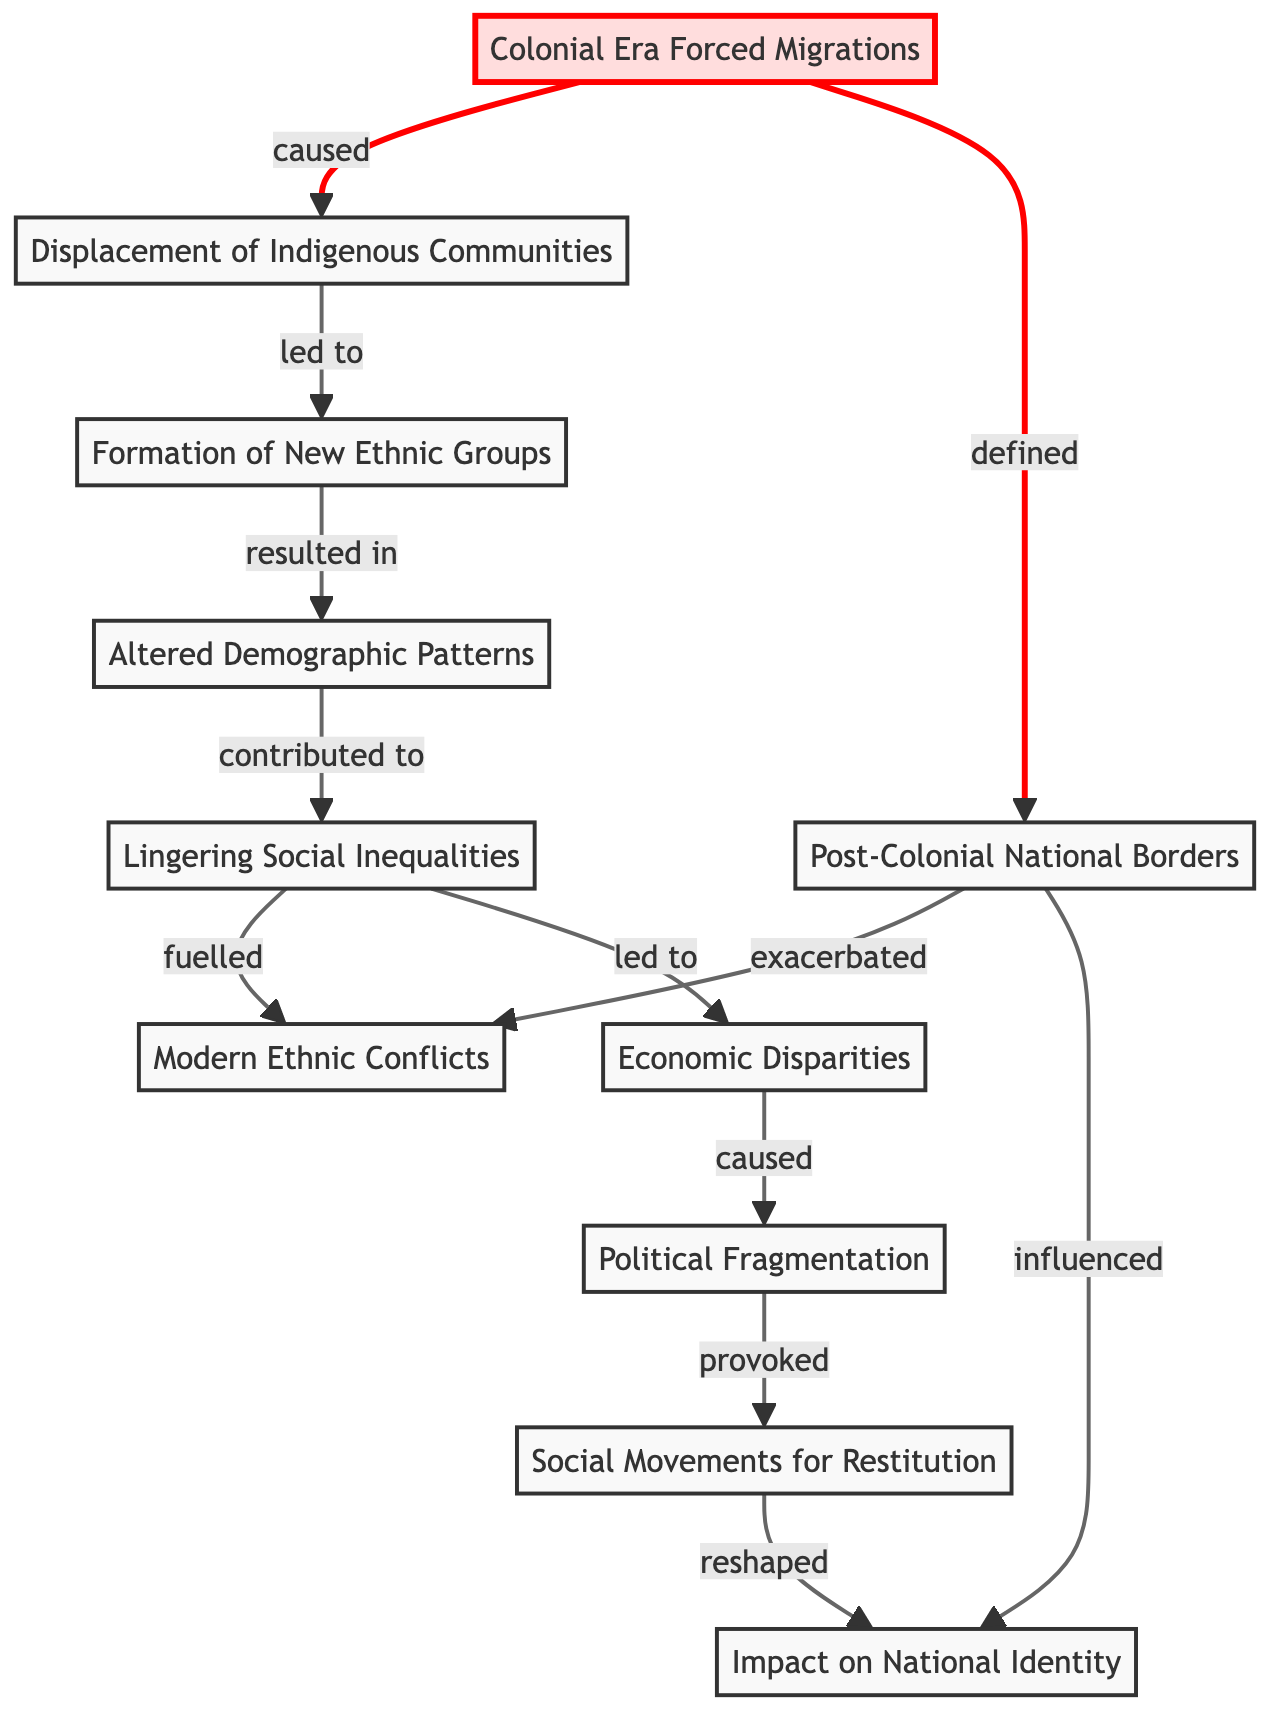What are the nodes in the diagram? The nodes in the diagram represent various concepts related to forced migrations and their impacts, including "Colonial Era Forced Migrations," "Displacement of Indigenous Communities," "Formation of New Ethnic Groups," "Altered Demographic Patterns," "Lingering Social Inequalities," "Modern Ethnic Conflicts," "Post-Colonial National Borders," "Economic Disparities," "Political Fragmentation," "Social Movements for Restitution," and "Impact on National Identity."
Answer: 11 What is the relationship between "Economic Disparities" and "Political Fragmentation"? "Economic Disparities" has an edge pointing to "Political Fragmentation" with the label "caused," indicating that economic inequalities lead to political fragmentation.
Answer: caused Which node directly follows "Displacement of Indigenous Communities"? The node directly following "Displacement of Indigenous Communities" is "Formation of New Ethnic Groups," indicating a direct consequence of the previous migration event.
Answer: Formation of New Ethnic Groups How many edges are in the diagram? By counting all the connections between nodes, there are 12 edges indicating the relationships and flows between the various concepts represented in the diagram.
Answer: 12 What is the final impact on "National Identity" in the diagram? The final impact on "National Identity" is influenced by "Post-Colonial National Borders" and reshaped by "Social Movements for Restitution," showcasing the complex interaction between migration history and modern identity.
Answer: reshaped What concept is most directly fueled by lingering social inequalities? "Modern Ethnic Conflicts" is the concept directly fueled by "Lingering Social Inequalities," depicting how unresolved disparities foster tensions among ethnic groups.
Answer: Modern Ethnic Conflicts What two nodes are connected through an edge labeled "exacerbated"? The nodes connected through the edge labeled "exacerbated" are "Post-Colonial National Borders" and "Modern Ethnic Conflicts," indicating that national boundaries established post-colonization intensified ethnic tensions.
Answer: Modern Ethnic Conflicts What caused "Lingering Social Inequalities"? "Lingering Social Inequalities" were caused by "Altered Demographic Patterns," which emerged due to the forced migrations during the colonial era, showcasing how demographic changes have lasting social implications.
Answer: Altered Demographic Patterns What node is connected to "Social Movements for Restitution"? "Social Movements for Restitution" is connected to "Impact on National Identity," which indicates that the movements aimed at addressing historical injustices reshaped the understanding of national identity.
Answer: Impact on National Identity 